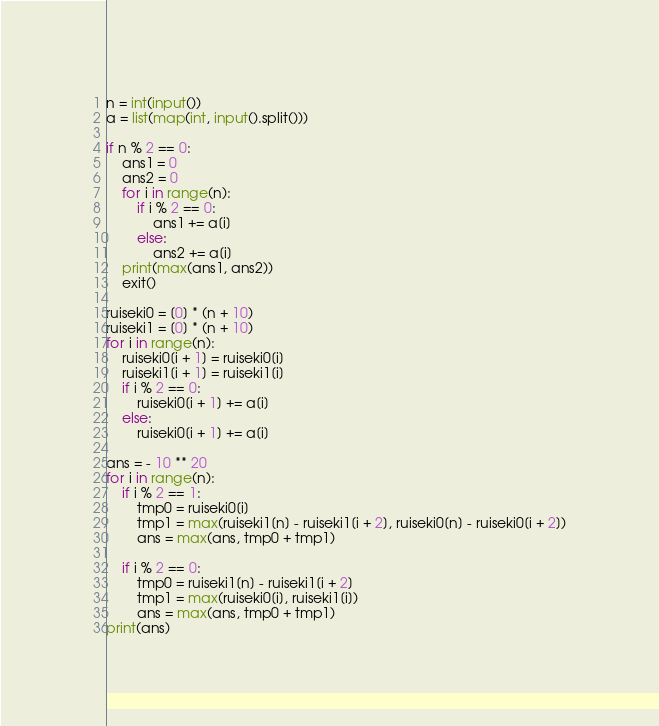Convert code to text. <code><loc_0><loc_0><loc_500><loc_500><_Python_>n = int(input())
a = list(map(int, input().split()))

if n % 2 == 0:
    ans1 = 0
    ans2 = 0
    for i in range(n):
        if i % 2 == 0:
            ans1 += a[i]
        else:
            ans2 += a[i]
    print(max(ans1, ans2))
    exit()

ruiseki0 = [0] * (n + 10) 
ruiseki1 = [0] * (n + 10) 
for i in range(n):
    ruiseki0[i + 1] = ruiseki0[i]
    ruiseki1[i + 1] = ruiseki1[i]
    if i % 2 == 0:
        ruiseki0[i + 1] += a[i]
    else:
        ruiseki0[i + 1] += a[i]

ans = - 10 ** 20
for i in range(n):
    if i % 2 == 1:
        tmp0 = ruiseki0[i]
        tmp1 = max(ruiseki1[n] - ruiseki1[i + 2], ruiseki0[n] - ruiseki0[i + 2])
        ans = max(ans, tmp0 + tmp1)

    if i % 2 == 0:
        tmp0 = ruiseki1[n] - ruiseki1[i + 2]
        tmp1 = max(ruiseki0[i], ruiseki1[i])
        ans = max(ans, tmp0 + tmp1)
print(ans)</code> 